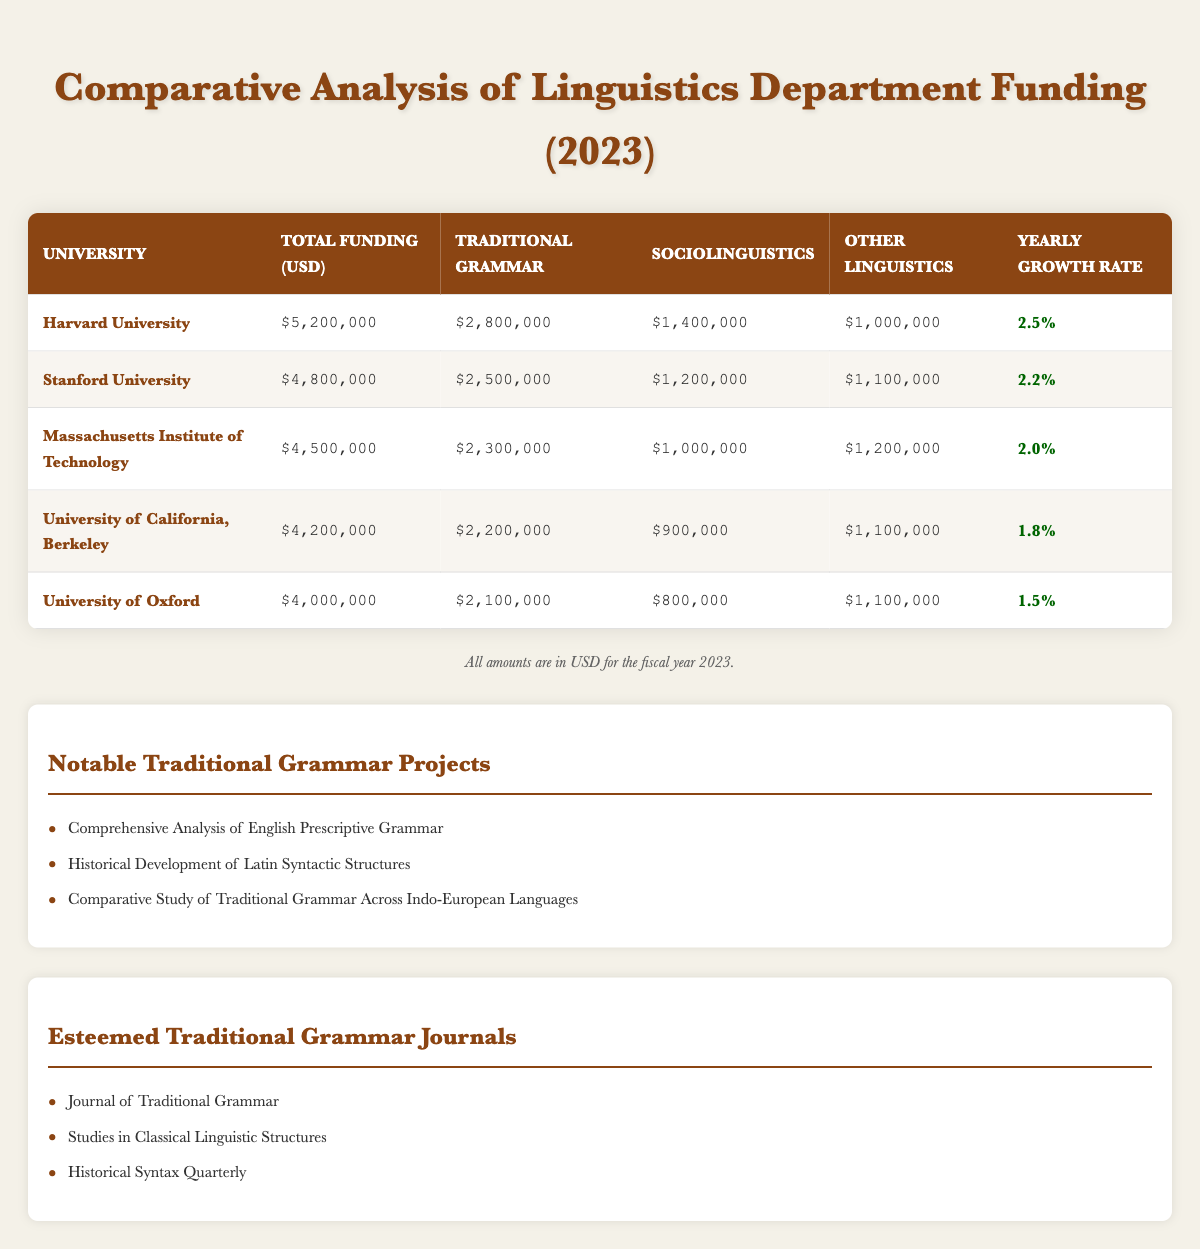What is the total funding allocated to Harvard University? Harvard University's total funding is directly listed in the table as $5,200,000.
Answer: $5,200,000 Which university has the highest funding for traditional grammar? By comparing the traditional grammar funding across all universities in the table, Harvard University has the highest amount at $2,800,000.
Answer: Harvard University What is the average funding for sociolinguistics across the five universities? To find the average sociolinguistics funding, sum the sociolinguistics amounts ($1,400,000 + $1,200,000 + $1,000,000 + $900,000 + $800,000 = $5,300,000) and divide by the number of universities (5), resulting in an average of $1,060,000.
Answer: $1,060,000 Is the yearly growth rate for the University of Oxford greater than 2%? The yearly growth rate for the University of Oxford is listed as 1.5%, which is less than 2%. Therefore, the statement is false.
Answer: No What percentage of the total linguistics department funding at Stanford University is allocated to traditional grammar? Stanford University's total linguistics funding is $4,800,000, with $2,500,000 allocated to traditional grammar. The percentage can be calculated as ($2,500,000 / $4,800,000) * 100 = 52.08%.
Answer: 52.08% If we consider only the traditional grammar funding, which university has the smallest amount, and what is that amount? By examining the traditional grammar funding amounts, the smallest is $2,100,000, allocated to the University of Oxford.
Answer: University of Oxford, $2,100,000 What is the total amount of funding for other linguistics across all listed universities? To calculate the total for other linguistics, sum the values: $1,000,000 + $1,100,000 + $1,200,000 + $1,100,000 + $1,100,000 = $5,600,000.
Answer: $5,600,000 Compare the yearly growth rates: are more than half of the listed universities achieving a growth rate below 2%? Out of the five universities, two have a growth rate below 2% (University of California, Berkeley at 1.8% and University of Oxford at 1.5%). Since two is not more than half of five, the answer is no.
Answer: No 